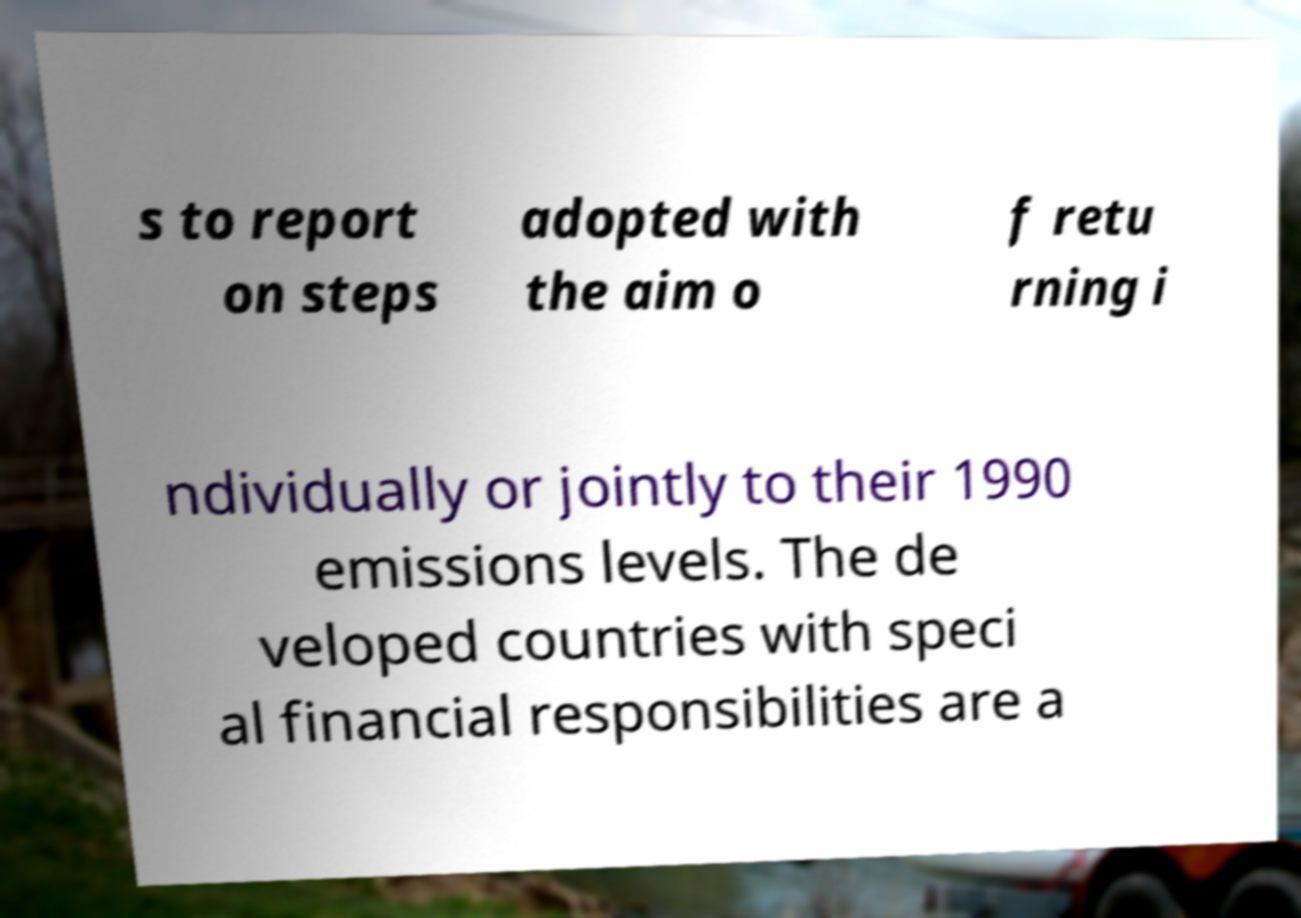What messages or text are displayed in this image? I need them in a readable, typed format. s to report on steps adopted with the aim o f retu rning i ndividually or jointly to their 1990 emissions levels. The de veloped countries with speci al financial responsibilities are a 